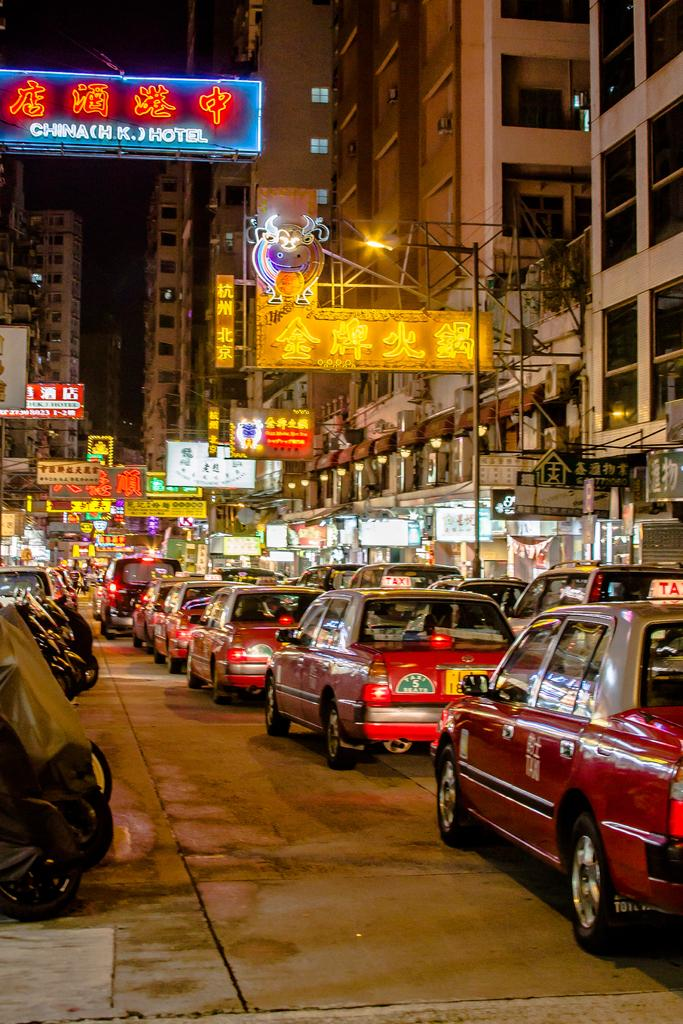<image>
Create a compact narrative representing the image presented. A red car with a TAXI sign on its roof is in traffic on a street with many signs. 